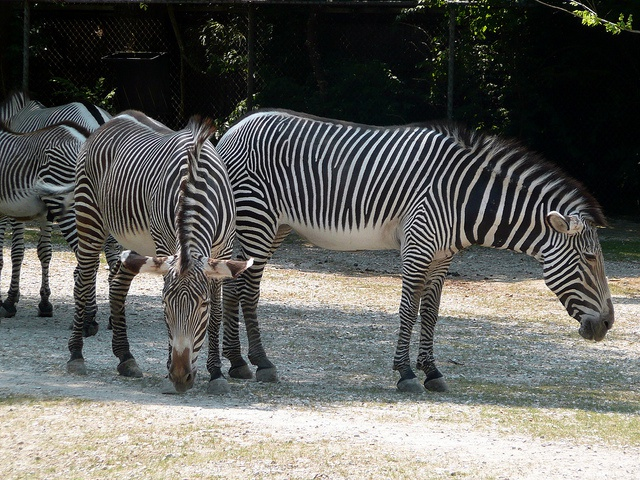Describe the objects in this image and their specific colors. I can see zebra in black, darkgray, gray, and lightgray tones, zebra in black, gray, and darkgray tones, zebra in black, gray, darkgray, and darkgreen tones, and zebra in black, gray, darkgray, and purple tones in this image. 